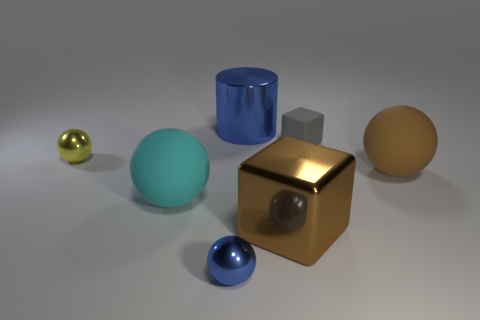What color is the other large matte object that is the same shape as the big brown matte thing?
Offer a very short reply. Cyan. The metallic object that is the same color as the metal cylinder is what shape?
Provide a short and direct response. Sphere. There is a blue thing in front of the cyan matte object; does it have the same size as the large blue metal cylinder?
Give a very brief answer. No. What number of other things are there of the same material as the cyan object
Provide a short and direct response. 2. How many green things are big cubes or big cylinders?
Keep it short and to the point. 0. What is the size of the rubber ball that is the same color as the metallic cube?
Provide a short and direct response. Large. There is a blue metal ball; what number of objects are to the right of it?
Make the answer very short. 4. How big is the blue thing that is behind the small shiny sphere in front of the metal sphere that is to the left of the blue shiny sphere?
Your answer should be compact. Large. Are there any tiny objects in front of the big thing on the left side of the tiny metallic ball on the right side of the cyan sphere?
Make the answer very short. Yes. Is the number of matte balls greater than the number of big brown metal blocks?
Ensure brevity in your answer.  Yes. 